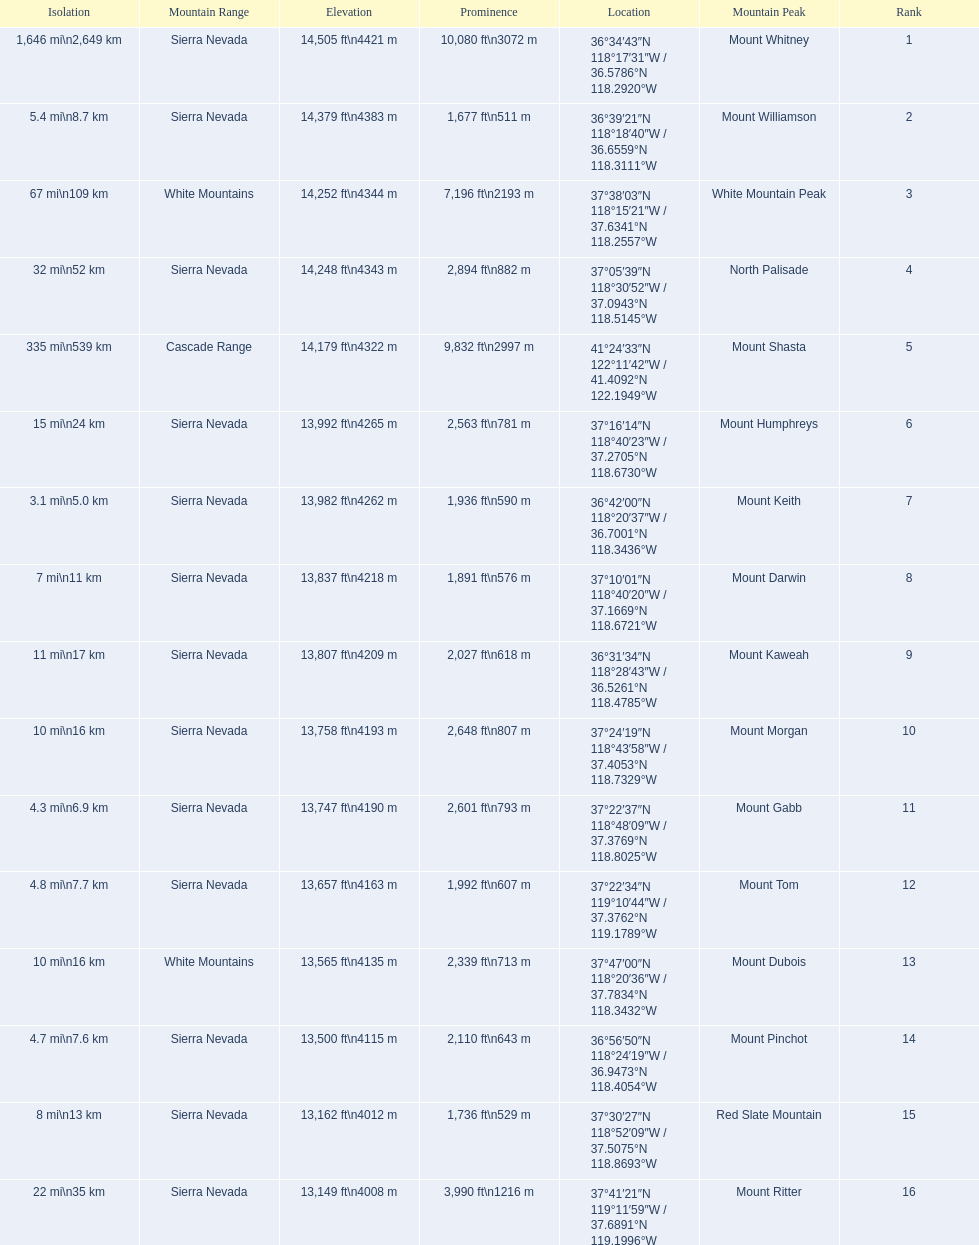What are all of the mountain peaks? Mount Whitney, Mount Williamson, White Mountain Peak, North Palisade, Mount Shasta, Mount Humphreys, Mount Keith, Mount Darwin, Mount Kaweah, Mount Morgan, Mount Gabb, Mount Tom, Mount Dubois, Mount Pinchot, Red Slate Mountain, Mount Ritter. In what ranges are they? Sierra Nevada, Sierra Nevada, White Mountains, Sierra Nevada, Cascade Range, Sierra Nevada, Sierra Nevada, Sierra Nevada, Sierra Nevada, Sierra Nevada, Sierra Nevada, Sierra Nevada, White Mountains, Sierra Nevada, Sierra Nevada, Sierra Nevada. Could you help me parse every detail presented in this table? {'header': ['Isolation', 'Mountain Range', 'Elevation', 'Prominence', 'Location', 'Mountain Peak', 'Rank'], 'rows': [['1,646\xa0mi\\n2,649\xa0km', 'Sierra Nevada', '14,505\xa0ft\\n4421\xa0m', '10,080\xa0ft\\n3072\xa0m', '36°34′43″N 118°17′31″W\ufeff / \ufeff36.5786°N 118.2920°W', 'Mount Whitney', '1'], ['5.4\xa0mi\\n8.7\xa0km', 'Sierra Nevada', '14,379\xa0ft\\n4383\xa0m', '1,677\xa0ft\\n511\xa0m', '36°39′21″N 118°18′40″W\ufeff / \ufeff36.6559°N 118.3111°W', 'Mount Williamson', '2'], ['67\xa0mi\\n109\xa0km', 'White Mountains', '14,252\xa0ft\\n4344\xa0m', '7,196\xa0ft\\n2193\xa0m', '37°38′03″N 118°15′21″W\ufeff / \ufeff37.6341°N 118.2557°W', 'White Mountain Peak', '3'], ['32\xa0mi\\n52\xa0km', 'Sierra Nevada', '14,248\xa0ft\\n4343\xa0m', '2,894\xa0ft\\n882\xa0m', '37°05′39″N 118°30′52″W\ufeff / \ufeff37.0943°N 118.5145°W', 'North Palisade', '4'], ['335\xa0mi\\n539\xa0km', 'Cascade Range', '14,179\xa0ft\\n4322\xa0m', '9,832\xa0ft\\n2997\xa0m', '41°24′33″N 122°11′42″W\ufeff / \ufeff41.4092°N 122.1949°W', 'Mount Shasta', '5'], ['15\xa0mi\\n24\xa0km', 'Sierra Nevada', '13,992\xa0ft\\n4265\xa0m', '2,563\xa0ft\\n781\xa0m', '37°16′14″N 118°40′23″W\ufeff / \ufeff37.2705°N 118.6730°W', 'Mount Humphreys', '6'], ['3.1\xa0mi\\n5.0\xa0km', 'Sierra Nevada', '13,982\xa0ft\\n4262\xa0m', '1,936\xa0ft\\n590\xa0m', '36°42′00″N 118°20′37″W\ufeff / \ufeff36.7001°N 118.3436°W', 'Mount Keith', '7'], ['7\xa0mi\\n11\xa0km', 'Sierra Nevada', '13,837\xa0ft\\n4218\xa0m', '1,891\xa0ft\\n576\xa0m', '37°10′01″N 118°40′20″W\ufeff / \ufeff37.1669°N 118.6721°W', 'Mount Darwin', '8'], ['11\xa0mi\\n17\xa0km', 'Sierra Nevada', '13,807\xa0ft\\n4209\xa0m', '2,027\xa0ft\\n618\xa0m', '36°31′34″N 118°28′43″W\ufeff / \ufeff36.5261°N 118.4785°W', 'Mount Kaweah', '9'], ['10\xa0mi\\n16\xa0km', 'Sierra Nevada', '13,758\xa0ft\\n4193\xa0m', '2,648\xa0ft\\n807\xa0m', '37°24′19″N 118°43′58″W\ufeff / \ufeff37.4053°N 118.7329°W', 'Mount Morgan', '10'], ['4.3\xa0mi\\n6.9\xa0km', 'Sierra Nevada', '13,747\xa0ft\\n4190\xa0m', '2,601\xa0ft\\n793\xa0m', '37°22′37″N 118°48′09″W\ufeff / \ufeff37.3769°N 118.8025°W', 'Mount Gabb', '11'], ['4.8\xa0mi\\n7.7\xa0km', 'Sierra Nevada', '13,657\xa0ft\\n4163\xa0m', '1,992\xa0ft\\n607\xa0m', '37°22′34″N 119°10′44″W\ufeff / \ufeff37.3762°N 119.1789°W', 'Mount Tom', '12'], ['10\xa0mi\\n16\xa0km', 'White Mountains', '13,565\xa0ft\\n4135\xa0m', '2,339\xa0ft\\n713\xa0m', '37°47′00″N 118°20′36″W\ufeff / \ufeff37.7834°N 118.3432°W', 'Mount Dubois', '13'], ['4.7\xa0mi\\n7.6\xa0km', 'Sierra Nevada', '13,500\xa0ft\\n4115\xa0m', '2,110\xa0ft\\n643\xa0m', '36°56′50″N 118°24′19″W\ufeff / \ufeff36.9473°N 118.4054°W', 'Mount Pinchot', '14'], ['8\xa0mi\\n13\xa0km', 'Sierra Nevada', '13,162\xa0ft\\n4012\xa0m', '1,736\xa0ft\\n529\xa0m', '37°30′27″N 118°52′09″W\ufeff / \ufeff37.5075°N 118.8693°W', 'Red Slate Mountain', '15'], ['22\xa0mi\\n35\xa0km', 'Sierra Nevada', '13,149\xa0ft\\n4008\xa0m', '3,990\xa0ft\\n1216\xa0m', '37°41′21″N 119°11′59″W\ufeff / \ufeff37.6891°N 119.1996°W', 'Mount Ritter', '16']]} Which peak is in the cascade range? Mount Shasta. 